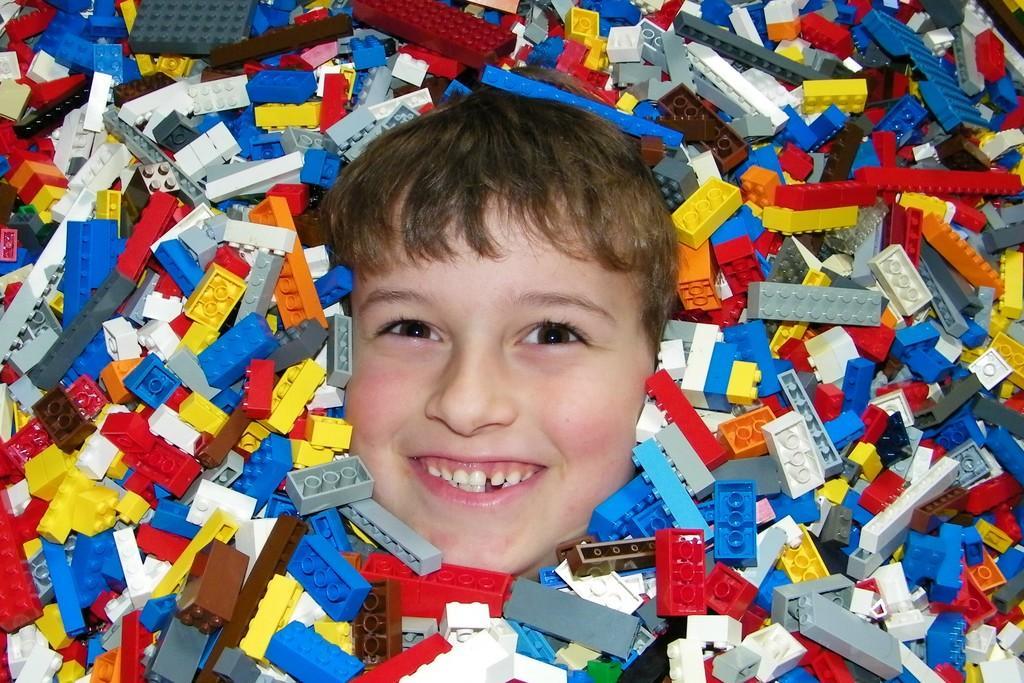Could you give a brief overview of what you see in this image? In this picture I can observe face of a boy in the middle of the picture. Around his face I can observe building blocks toys. They are in different colors. 